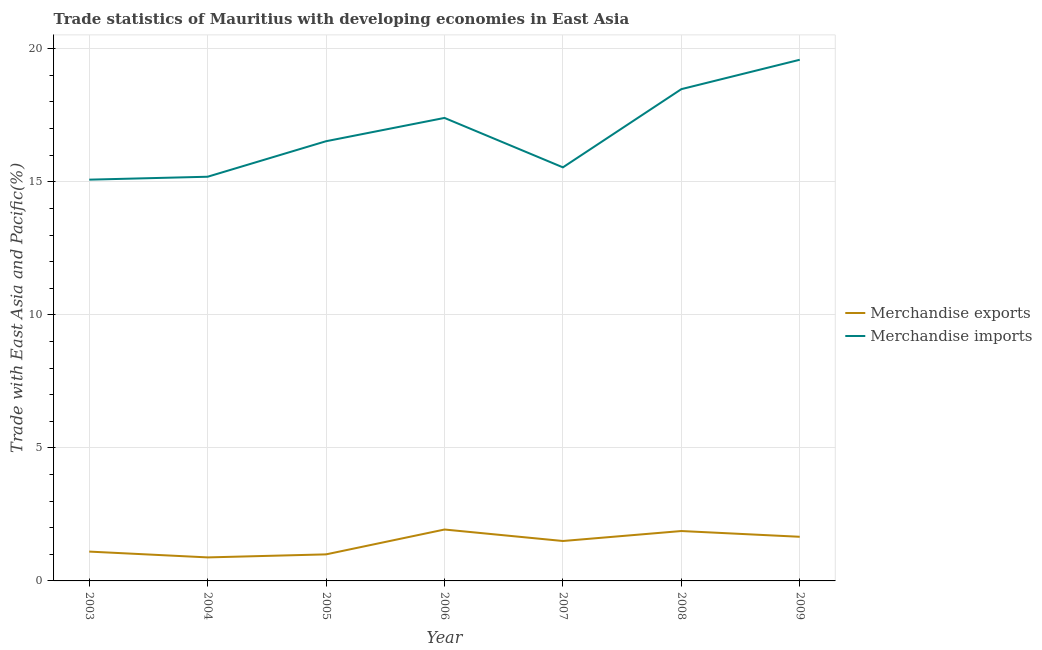How many different coloured lines are there?
Ensure brevity in your answer.  2. Does the line corresponding to merchandise imports intersect with the line corresponding to merchandise exports?
Your answer should be compact. No. What is the merchandise exports in 2005?
Your answer should be very brief. 1. Across all years, what is the maximum merchandise imports?
Give a very brief answer. 19.59. Across all years, what is the minimum merchandise imports?
Your answer should be very brief. 15.08. In which year was the merchandise exports maximum?
Make the answer very short. 2006. What is the total merchandise imports in the graph?
Your answer should be very brief. 117.81. What is the difference between the merchandise exports in 2004 and that in 2009?
Give a very brief answer. -0.78. What is the difference between the merchandise exports in 2003 and the merchandise imports in 2005?
Make the answer very short. -15.42. What is the average merchandise exports per year?
Your answer should be very brief. 1.42. In the year 2009, what is the difference between the merchandise exports and merchandise imports?
Offer a very short reply. -17.93. What is the ratio of the merchandise imports in 2004 to that in 2005?
Ensure brevity in your answer.  0.92. What is the difference between the highest and the second highest merchandise exports?
Keep it short and to the point. 0.06. What is the difference between the highest and the lowest merchandise imports?
Provide a short and direct response. 4.51. In how many years, is the merchandise exports greater than the average merchandise exports taken over all years?
Keep it short and to the point. 4. Is the sum of the merchandise exports in 2004 and 2007 greater than the maximum merchandise imports across all years?
Keep it short and to the point. No. Does the merchandise imports monotonically increase over the years?
Provide a succinct answer. No. Is the merchandise exports strictly less than the merchandise imports over the years?
Ensure brevity in your answer.  Yes. Where does the legend appear in the graph?
Your answer should be very brief. Center right. How many legend labels are there?
Your answer should be compact. 2. How are the legend labels stacked?
Your response must be concise. Vertical. What is the title of the graph?
Your response must be concise. Trade statistics of Mauritius with developing economies in East Asia. What is the label or title of the X-axis?
Provide a succinct answer. Year. What is the label or title of the Y-axis?
Your response must be concise. Trade with East Asia and Pacific(%). What is the Trade with East Asia and Pacific(%) of Merchandise exports in 2003?
Keep it short and to the point. 1.1. What is the Trade with East Asia and Pacific(%) in Merchandise imports in 2003?
Your response must be concise. 15.08. What is the Trade with East Asia and Pacific(%) in Merchandise exports in 2004?
Offer a terse response. 0.88. What is the Trade with East Asia and Pacific(%) in Merchandise imports in 2004?
Provide a short and direct response. 15.19. What is the Trade with East Asia and Pacific(%) of Merchandise exports in 2005?
Provide a succinct answer. 1. What is the Trade with East Asia and Pacific(%) in Merchandise imports in 2005?
Provide a succinct answer. 16.53. What is the Trade with East Asia and Pacific(%) in Merchandise exports in 2006?
Offer a very short reply. 1.93. What is the Trade with East Asia and Pacific(%) of Merchandise imports in 2006?
Your response must be concise. 17.4. What is the Trade with East Asia and Pacific(%) in Merchandise exports in 2007?
Offer a terse response. 1.5. What is the Trade with East Asia and Pacific(%) in Merchandise imports in 2007?
Give a very brief answer. 15.54. What is the Trade with East Asia and Pacific(%) in Merchandise exports in 2008?
Keep it short and to the point. 1.88. What is the Trade with East Asia and Pacific(%) of Merchandise imports in 2008?
Offer a very short reply. 18.48. What is the Trade with East Asia and Pacific(%) in Merchandise exports in 2009?
Your answer should be compact. 1.66. What is the Trade with East Asia and Pacific(%) in Merchandise imports in 2009?
Your answer should be compact. 19.59. Across all years, what is the maximum Trade with East Asia and Pacific(%) in Merchandise exports?
Your response must be concise. 1.93. Across all years, what is the maximum Trade with East Asia and Pacific(%) of Merchandise imports?
Your response must be concise. 19.59. Across all years, what is the minimum Trade with East Asia and Pacific(%) of Merchandise exports?
Ensure brevity in your answer.  0.88. Across all years, what is the minimum Trade with East Asia and Pacific(%) of Merchandise imports?
Your answer should be compact. 15.08. What is the total Trade with East Asia and Pacific(%) of Merchandise exports in the graph?
Give a very brief answer. 9.95. What is the total Trade with East Asia and Pacific(%) in Merchandise imports in the graph?
Give a very brief answer. 117.81. What is the difference between the Trade with East Asia and Pacific(%) in Merchandise exports in 2003 and that in 2004?
Your response must be concise. 0.22. What is the difference between the Trade with East Asia and Pacific(%) in Merchandise imports in 2003 and that in 2004?
Offer a terse response. -0.11. What is the difference between the Trade with East Asia and Pacific(%) in Merchandise exports in 2003 and that in 2005?
Offer a very short reply. 0.1. What is the difference between the Trade with East Asia and Pacific(%) in Merchandise imports in 2003 and that in 2005?
Make the answer very short. -1.44. What is the difference between the Trade with East Asia and Pacific(%) of Merchandise exports in 2003 and that in 2006?
Ensure brevity in your answer.  -0.83. What is the difference between the Trade with East Asia and Pacific(%) of Merchandise imports in 2003 and that in 2006?
Offer a terse response. -2.32. What is the difference between the Trade with East Asia and Pacific(%) in Merchandise exports in 2003 and that in 2007?
Your answer should be very brief. -0.4. What is the difference between the Trade with East Asia and Pacific(%) of Merchandise imports in 2003 and that in 2007?
Offer a terse response. -0.46. What is the difference between the Trade with East Asia and Pacific(%) of Merchandise exports in 2003 and that in 2008?
Make the answer very short. -0.77. What is the difference between the Trade with East Asia and Pacific(%) of Merchandise imports in 2003 and that in 2008?
Ensure brevity in your answer.  -3.4. What is the difference between the Trade with East Asia and Pacific(%) of Merchandise exports in 2003 and that in 2009?
Keep it short and to the point. -0.56. What is the difference between the Trade with East Asia and Pacific(%) of Merchandise imports in 2003 and that in 2009?
Offer a very short reply. -4.51. What is the difference between the Trade with East Asia and Pacific(%) of Merchandise exports in 2004 and that in 2005?
Your answer should be very brief. -0.11. What is the difference between the Trade with East Asia and Pacific(%) in Merchandise imports in 2004 and that in 2005?
Make the answer very short. -1.33. What is the difference between the Trade with East Asia and Pacific(%) of Merchandise exports in 2004 and that in 2006?
Your answer should be very brief. -1.05. What is the difference between the Trade with East Asia and Pacific(%) in Merchandise imports in 2004 and that in 2006?
Provide a short and direct response. -2.21. What is the difference between the Trade with East Asia and Pacific(%) of Merchandise exports in 2004 and that in 2007?
Ensure brevity in your answer.  -0.62. What is the difference between the Trade with East Asia and Pacific(%) of Merchandise imports in 2004 and that in 2007?
Provide a short and direct response. -0.35. What is the difference between the Trade with East Asia and Pacific(%) of Merchandise exports in 2004 and that in 2008?
Keep it short and to the point. -0.99. What is the difference between the Trade with East Asia and Pacific(%) of Merchandise imports in 2004 and that in 2008?
Offer a very short reply. -3.29. What is the difference between the Trade with East Asia and Pacific(%) of Merchandise exports in 2004 and that in 2009?
Ensure brevity in your answer.  -0.78. What is the difference between the Trade with East Asia and Pacific(%) in Merchandise imports in 2004 and that in 2009?
Offer a terse response. -4.4. What is the difference between the Trade with East Asia and Pacific(%) in Merchandise exports in 2005 and that in 2006?
Offer a terse response. -0.93. What is the difference between the Trade with East Asia and Pacific(%) of Merchandise imports in 2005 and that in 2006?
Your answer should be compact. -0.88. What is the difference between the Trade with East Asia and Pacific(%) of Merchandise exports in 2005 and that in 2007?
Offer a very short reply. -0.5. What is the difference between the Trade with East Asia and Pacific(%) of Merchandise imports in 2005 and that in 2007?
Your answer should be compact. 0.98. What is the difference between the Trade with East Asia and Pacific(%) of Merchandise exports in 2005 and that in 2008?
Provide a succinct answer. -0.88. What is the difference between the Trade with East Asia and Pacific(%) of Merchandise imports in 2005 and that in 2008?
Offer a terse response. -1.96. What is the difference between the Trade with East Asia and Pacific(%) of Merchandise exports in 2005 and that in 2009?
Your answer should be compact. -0.66. What is the difference between the Trade with East Asia and Pacific(%) in Merchandise imports in 2005 and that in 2009?
Your answer should be compact. -3.06. What is the difference between the Trade with East Asia and Pacific(%) of Merchandise exports in 2006 and that in 2007?
Your response must be concise. 0.43. What is the difference between the Trade with East Asia and Pacific(%) in Merchandise imports in 2006 and that in 2007?
Offer a terse response. 1.86. What is the difference between the Trade with East Asia and Pacific(%) in Merchandise exports in 2006 and that in 2008?
Offer a very short reply. 0.06. What is the difference between the Trade with East Asia and Pacific(%) of Merchandise imports in 2006 and that in 2008?
Offer a very short reply. -1.08. What is the difference between the Trade with East Asia and Pacific(%) in Merchandise exports in 2006 and that in 2009?
Ensure brevity in your answer.  0.27. What is the difference between the Trade with East Asia and Pacific(%) in Merchandise imports in 2006 and that in 2009?
Give a very brief answer. -2.19. What is the difference between the Trade with East Asia and Pacific(%) of Merchandise exports in 2007 and that in 2008?
Your answer should be very brief. -0.37. What is the difference between the Trade with East Asia and Pacific(%) in Merchandise imports in 2007 and that in 2008?
Offer a very short reply. -2.94. What is the difference between the Trade with East Asia and Pacific(%) in Merchandise exports in 2007 and that in 2009?
Ensure brevity in your answer.  -0.16. What is the difference between the Trade with East Asia and Pacific(%) in Merchandise imports in 2007 and that in 2009?
Ensure brevity in your answer.  -4.04. What is the difference between the Trade with East Asia and Pacific(%) in Merchandise exports in 2008 and that in 2009?
Your answer should be very brief. 0.22. What is the difference between the Trade with East Asia and Pacific(%) of Merchandise imports in 2008 and that in 2009?
Provide a short and direct response. -1.1. What is the difference between the Trade with East Asia and Pacific(%) in Merchandise exports in 2003 and the Trade with East Asia and Pacific(%) in Merchandise imports in 2004?
Offer a very short reply. -14.09. What is the difference between the Trade with East Asia and Pacific(%) of Merchandise exports in 2003 and the Trade with East Asia and Pacific(%) of Merchandise imports in 2005?
Your answer should be compact. -15.42. What is the difference between the Trade with East Asia and Pacific(%) in Merchandise exports in 2003 and the Trade with East Asia and Pacific(%) in Merchandise imports in 2006?
Ensure brevity in your answer.  -16.3. What is the difference between the Trade with East Asia and Pacific(%) in Merchandise exports in 2003 and the Trade with East Asia and Pacific(%) in Merchandise imports in 2007?
Make the answer very short. -14.44. What is the difference between the Trade with East Asia and Pacific(%) in Merchandise exports in 2003 and the Trade with East Asia and Pacific(%) in Merchandise imports in 2008?
Provide a succinct answer. -17.38. What is the difference between the Trade with East Asia and Pacific(%) in Merchandise exports in 2003 and the Trade with East Asia and Pacific(%) in Merchandise imports in 2009?
Ensure brevity in your answer.  -18.48. What is the difference between the Trade with East Asia and Pacific(%) of Merchandise exports in 2004 and the Trade with East Asia and Pacific(%) of Merchandise imports in 2005?
Your response must be concise. -15.64. What is the difference between the Trade with East Asia and Pacific(%) of Merchandise exports in 2004 and the Trade with East Asia and Pacific(%) of Merchandise imports in 2006?
Your answer should be compact. -16.52. What is the difference between the Trade with East Asia and Pacific(%) of Merchandise exports in 2004 and the Trade with East Asia and Pacific(%) of Merchandise imports in 2007?
Your answer should be compact. -14.66. What is the difference between the Trade with East Asia and Pacific(%) of Merchandise exports in 2004 and the Trade with East Asia and Pacific(%) of Merchandise imports in 2008?
Ensure brevity in your answer.  -17.6. What is the difference between the Trade with East Asia and Pacific(%) in Merchandise exports in 2004 and the Trade with East Asia and Pacific(%) in Merchandise imports in 2009?
Provide a short and direct response. -18.7. What is the difference between the Trade with East Asia and Pacific(%) in Merchandise exports in 2005 and the Trade with East Asia and Pacific(%) in Merchandise imports in 2006?
Offer a terse response. -16.4. What is the difference between the Trade with East Asia and Pacific(%) of Merchandise exports in 2005 and the Trade with East Asia and Pacific(%) of Merchandise imports in 2007?
Ensure brevity in your answer.  -14.55. What is the difference between the Trade with East Asia and Pacific(%) of Merchandise exports in 2005 and the Trade with East Asia and Pacific(%) of Merchandise imports in 2008?
Give a very brief answer. -17.48. What is the difference between the Trade with East Asia and Pacific(%) in Merchandise exports in 2005 and the Trade with East Asia and Pacific(%) in Merchandise imports in 2009?
Your answer should be compact. -18.59. What is the difference between the Trade with East Asia and Pacific(%) in Merchandise exports in 2006 and the Trade with East Asia and Pacific(%) in Merchandise imports in 2007?
Provide a succinct answer. -13.61. What is the difference between the Trade with East Asia and Pacific(%) in Merchandise exports in 2006 and the Trade with East Asia and Pacific(%) in Merchandise imports in 2008?
Provide a short and direct response. -16.55. What is the difference between the Trade with East Asia and Pacific(%) of Merchandise exports in 2006 and the Trade with East Asia and Pacific(%) of Merchandise imports in 2009?
Offer a very short reply. -17.66. What is the difference between the Trade with East Asia and Pacific(%) of Merchandise exports in 2007 and the Trade with East Asia and Pacific(%) of Merchandise imports in 2008?
Provide a short and direct response. -16.98. What is the difference between the Trade with East Asia and Pacific(%) of Merchandise exports in 2007 and the Trade with East Asia and Pacific(%) of Merchandise imports in 2009?
Your answer should be compact. -18.09. What is the difference between the Trade with East Asia and Pacific(%) in Merchandise exports in 2008 and the Trade with East Asia and Pacific(%) in Merchandise imports in 2009?
Keep it short and to the point. -17.71. What is the average Trade with East Asia and Pacific(%) in Merchandise exports per year?
Your answer should be compact. 1.42. What is the average Trade with East Asia and Pacific(%) of Merchandise imports per year?
Your answer should be very brief. 16.83. In the year 2003, what is the difference between the Trade with East Asia and Pacific(%) of Merchandise exports and Trade with East Asia and Pacific(%) of Merchandise imports?
Make the answer very short. -13.98. In the year 2004, what is the difference between the Trade with East Asia and Pacific(%) of Merchandise exports and Trade with East Asia and Pacific(%) of Merchandise imports?
Keep it short and to the point. -14.31. In the year 2005, what is the difference between the Trade with East Asia and Pacific(%) of Merchandise exports and Trade with East Asia and Pacific(%) of Merchandise imports?
Make the answer very short. -15.53. In the year 2006, what is the difference between the Trade with East Asia and Pacific(%) in Merchandise exports and Trade with East Asia and Pacific(%) in Merchandise imports?
Provide a succinct answer. -15.47. In the year 2007, what is the difference between the Trade with East Asia and Pacific(%) in Merchandise exports and Trade with East Asia and Pacific(%) in Merchandise imports?
Ensure brevity in your answer.  -14.04. In the year 2008, what is the difference between the Trade with East Asia and Pacific(%) of Merchandise exports and Trade with East Asia and Pacific(%) of Merchandise imports?
Give a very brief answer. -16.61. In the year 2009, what is the difference between the Trade with East Asia and Pacific(%) of Merchandise exports and Trade with East Asia and Pacific(%) of Merchandise imports?
Keep it short and to the point. -17.93. What is the ratio of the Trade with East Asia and Pacific(%) of Merchandise exports in 2003 to that in 2004?
Offer a very short reply. 1.25. What is the ratio of the Trade with East Asia and Pacific(%) of Merchandise imports in 2003 to that in 2004?
Your answer should be compact. 0.99. What is the ratio of the Trade with East Asia and Pacific(%) of Merchandise exports in 2003 to that in 2005?
Provide a succinct answer. 1.1. What is the ratio of the Trade with East Asia and Pacific(%) in Merchandise imports in 2003 to that in 2005?
Ensure brevity in your answer.  0.91. What is the ratio of the Trade with East Asia and Pacific(%) of Merchandise exports in 2003 to that in 2006?
Give a very brief answer. 0.57. What is the ratio of the Trade with East Asia and Pacific(%) of Merchandise imports in 2003 to that in 2006?
Make the answer very short. 0.87. What is the ratio of the Trade with East Asia and Pacific(%) of Merchandise exports in 2003 to that in 2007?
Keep it short and to the point. 0.73. What is the ratio of the Trade with East Asia and Pacific(%) of Merchandise imports in 2003 to that in 2007?
Your answer should be very brief. 0.97. What is the ratio of the Trade with East Asia and Pacific(%) of Merchandise exports in 2003 to that in 2008?
Provide a succinct answer. 0.59. What is the ratio of the Trade with East Asia and Pacific(%) in Merchandise imports in 2003 to that in 2008?
Provide a succinct answer. 0.82. What is the ratio of the Trade with East Asia and Pacific(%) of Merchandise exports in 2003 to that in 2009?
Provide a succinct answer. 0.66. What is the ratio of the Trade with East Asia and Pacific(%) in Merchandise imports in 2003 to that in 2009?
Offer a very short reply. 0.77. What is the ratio of the Trade with East Asia and Pacific(%) of Merchandise exports in 2004 to that in 2005?
Keep it short and to the point. 0.89. What is the ratio of the Trade with East Asia and Pacific(%) of Merchandise imports in 2004 to that in 2005?
Ensure brevity in your answer.  0.92. What is the ratio of the Trade with East Asia and Pacific(%) in Merchandise exports in 2004 to that in 2006?
Provide a succinct answer. 0.46. What is the ratio of the Trade with East Asia and Pacific(%) of Merchandise imports in 2004 to that in 2006?
Your answer should be very brief. 0.87. What is the ratio of the Trade with East Asia and Pacific(%) of Merchandise exports in 2004 to that in 2007?
Your answer should be very brief. 0.59. What is the ratio of the Trade with East Asia and Pacific(%) of Merchandise imports in 2004 to that in 2007?
Give a very brief answer. 0.98. What is the ratio of the Trade with East Asia and Pacific(%) of Merchandise exports in 2004 to that in 2008?
Ensure brevity in your answer.  0.47. What is the ratio of the Trade with East Asia and Pacific(%) of Merchandise imports in 2004 to that in 2008?
Give a very brief answer. 0.82. What is the ratio of the Trade with East Asia and Pacific(%) of Merchandise exports in 2004 to that in 2009?
Give a very brief answer. 0.53. What is the ratio of the Trade with East Asia and Pacific(%) in Merchandise imports in 2004 to that in 2009?
Offer a terse response. 0.78. What is the ratio of the Trade with East Asia and Pacific(%) of Merchandise exports in 2005 to that in 2006?
Offer a very short reply. 0.52. What is the ratio of the Trade with East Asia and Pacific(%) in Merchandise imports in 2005 to that in 2006?
Your response must be concise. 0.95. What is the ratio of the Trade with East Asia and Pacific(%) in Merchandise exports in 2005 to that in 2007?
Make the answer very short. 0.67. What is the ratio of the Trade with East Asia and Pacific(%) in Merchandise imports in 2005 to that in 2007?
Provide a short and direct response. 1.06. What is the ratio of the Trade with East Asia and Pacific(%) of Merchandise exports in 2005 to that in 2008?
Your response must be concise. 0.53. What is the ratio of the Trade with East Asia and Pacific(%) in Merchandise imports in 2005 to that in 2008?
Your answer should be compact. 0.89. What is the ratio of the Trade with East Asia and Pacific(%) in Merchandise exports in 2005 to that in 2009?
Your answer should be very brief. 0.6. What is the ratio of the Trade with East Asia and Pacific(%) in Merchandise imports in 2005 to that in 2009?
Keep it short and to the point. 0.84. What is the ratio of the Trade with East Asia and Pacific(%) in Merchandise exports in 2006 to that in 2007?
Your answer should be compact. 1.29. What is the ratio of the Trade with East Asia and Pacific(%) of Merchandise imports in 2006 to that in 2007?
Provide a short and direct response. 1.12. What is the ratio of the Trade with East Asia and Pacific(%) of Merchandise exports in 2006 to that in 2008?
Make the answer very short. 1.03. What is the ratio of the Trade with East Asia and Pacific(%) in Merchandise imports in 2006 to that in 2008?
Give a very brief answer. 0.94. What is the ratio of the Trade with East Asia and Pacific(%) of Merchandise exports in 2006 to that in 2009?
Make the answer very short. 1.16. What is the ratio of the Trade with East Asia and Pacific(%) of Merchandise imports in 2006 to that in 2009?
Provide a short and direct response. 0.89. What is the ratio of the Trade with East Asia and Pacific(%) of Merchandise exports in 2007 to that in 2008?
Offer a very short reply. 0.8. What is the ratio of the Trade with East Asia and Pacific(%) in Merchandise imports in 2007 to that in 2008?
Keep it short and to the point. 0.84. What is the ratio of the Trade with East Asia and Pacific(%) in Merchandise exports in 2007 to that in 2009?
Give a very brief answer. 0.9. What is the ratio of the Trade with East Asia and Pacific(%) of Merchandise imports in 2007 to that in 2009?
Offer a terse response. 0.79. What is the ratio of the Trade with East Asia and Pacific(%) in Merchandise exports in 2008 to that in 2009?
Your response must be concise. 1.13. What is the ratio of the Trade with East Asia and Pacific(%) of Merchandise imports in 2008 to that in 2009?
Your response must be concise. 0.94. What is the difference between the highest and the second highest Trade with East Asia and Pacific(%) in Merchandise exports?
Your answer should be compact. 0.06. What is the difference between the highest and the second highest Trade with East Asia and Pacific(%) of Merchandise imports?
Offer a very short reply. 1.1. What is the difference between the highest and the lowest Trade with East Asia and Pacific(%) in Merchandise exports?
Make the answer very short. 1.05. What is the difference between the highest and the lowest Trade with East Asia and Pacific(%) of Merchandise imports?
Provide a succinct answer. 4.51. 